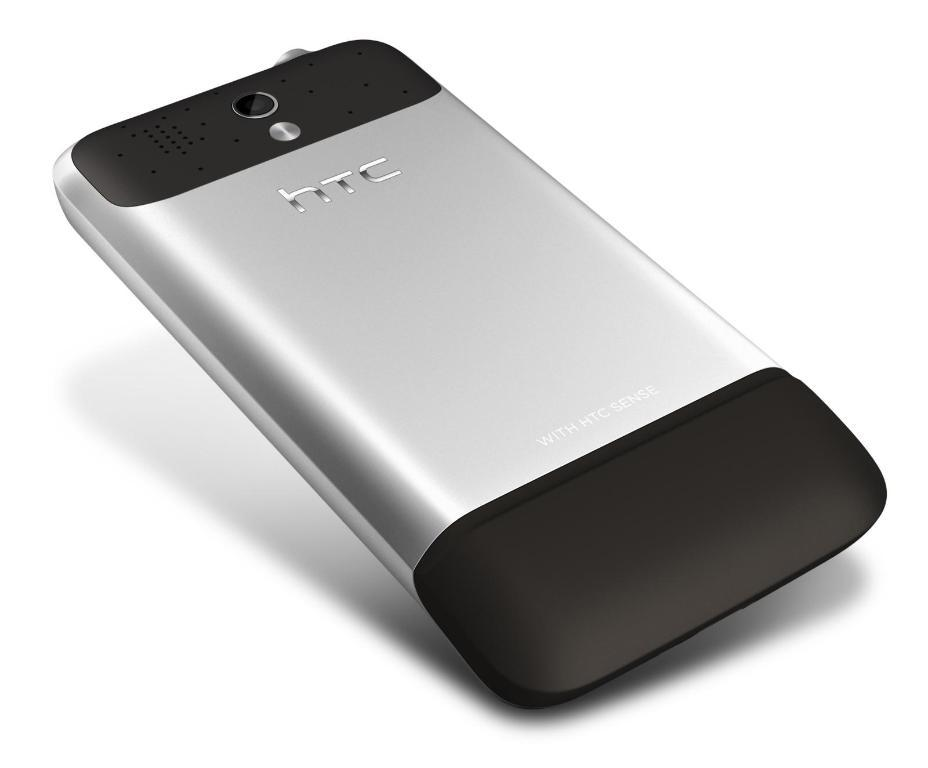<image>
Summarize the visual content of the image. A silvere and black HTC cell phone on a white background. 